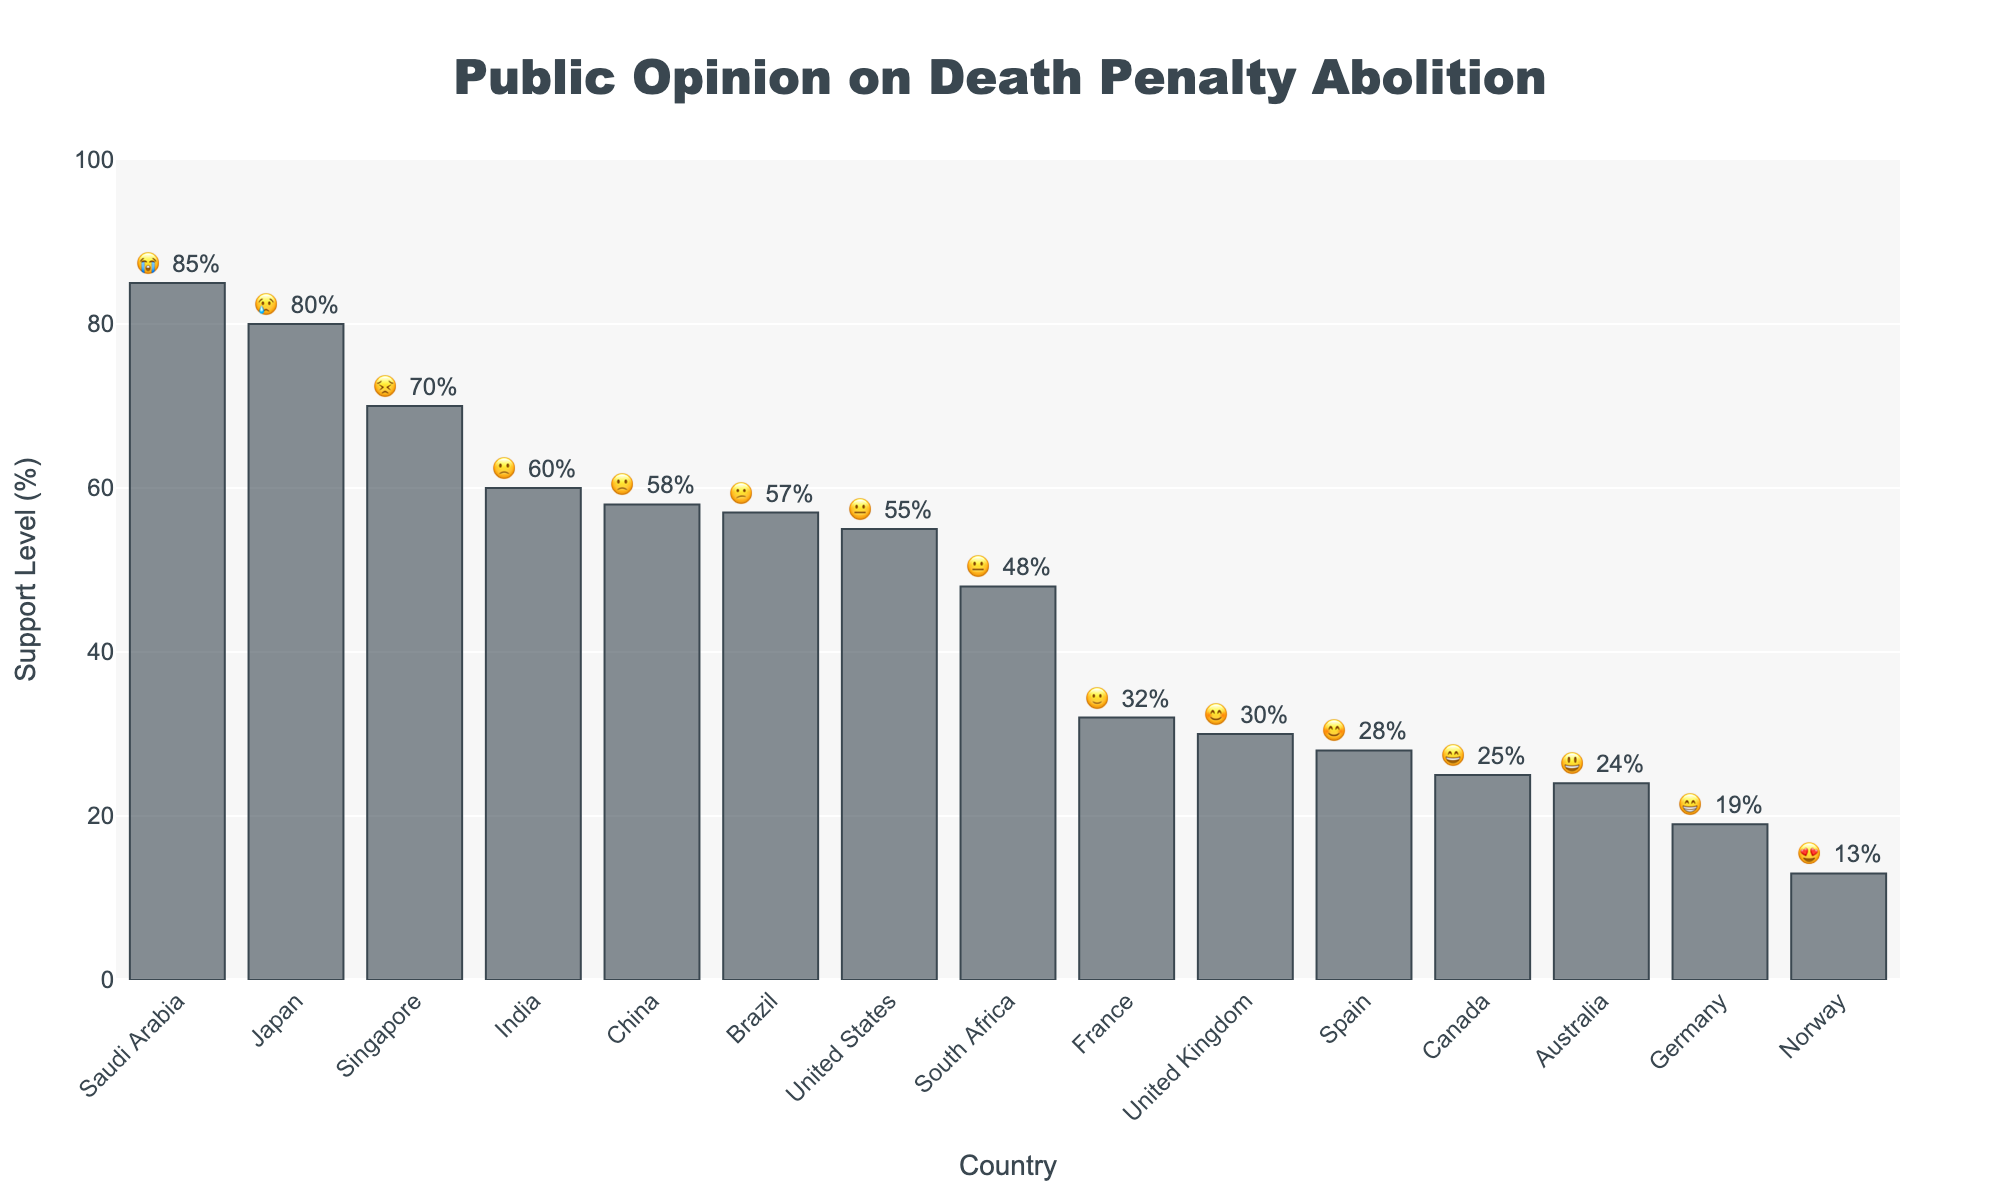What is the title of the figure? The title is usually displayed prominently at the top of the figure to give a clear idea of what the chart represents.
Answer: Public Opinion on Death Penalty Abolition Which country has the highest support level for the death penalty abolition? The country with the highest bar in the chart represents the highest support level. Look at the percentage labels for exact values.
Answer: Saudi Arabia What's the emoji representing Canada's support level? Check the bar corresponding to Canada and note the emoji displayed alongside the percentage value.
Answer: 😄 Between China and India, which country has a higher support level for death penalty abolition? Compare the height of the bars and the percentage values for China and India to see which is higher.
Answer: India What's the average support level of the countries shown in the chart? Add up all the support levels (55 + 30 + 58 + 25 + 80 + 19 + 32 + 24 + 57 + 48 + 13 + 70 + 60 + 28 + 85) and divide by the number of countries (15).
Answer: 44.8% Which country has the lowest support level for the death penalty abolition? The bar with the smallest height and percentage value will represent the country with the lowest support level.
Answer: Norway How many countries have a support level less than 30% for death penalty abolition? Identify and count the bars that have a percentage value under 30%.
Answer: Three (Canada, Germany, Norway) What kind of emoji faces are used to express support levels? Look at the different emojis placed next to each bar in the chart.
Answer: 😊, 😢, 😃, 😄, 😁, 😐, 🙁, 😕, 😣, 😭, 🙂 What is the difference in support level between the United States and the United Kingdom? Subtract the support level of the United Kingdom from that of the United States (55% - 30%).
Answer: 25% Which country shows a 'neutral' emoji face (😐) indicating support level? Find the country associated with the 😐 emoji from the chart.
Answer: United States 